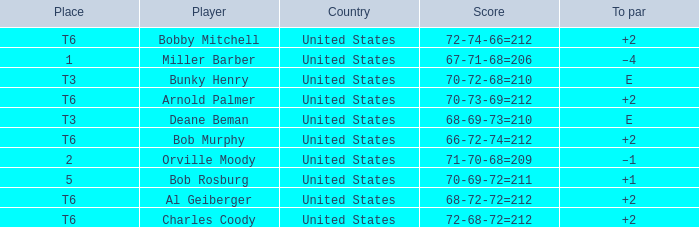Who is the player with a t6 place and a 72-68-72=212 score? Charles Coody. 